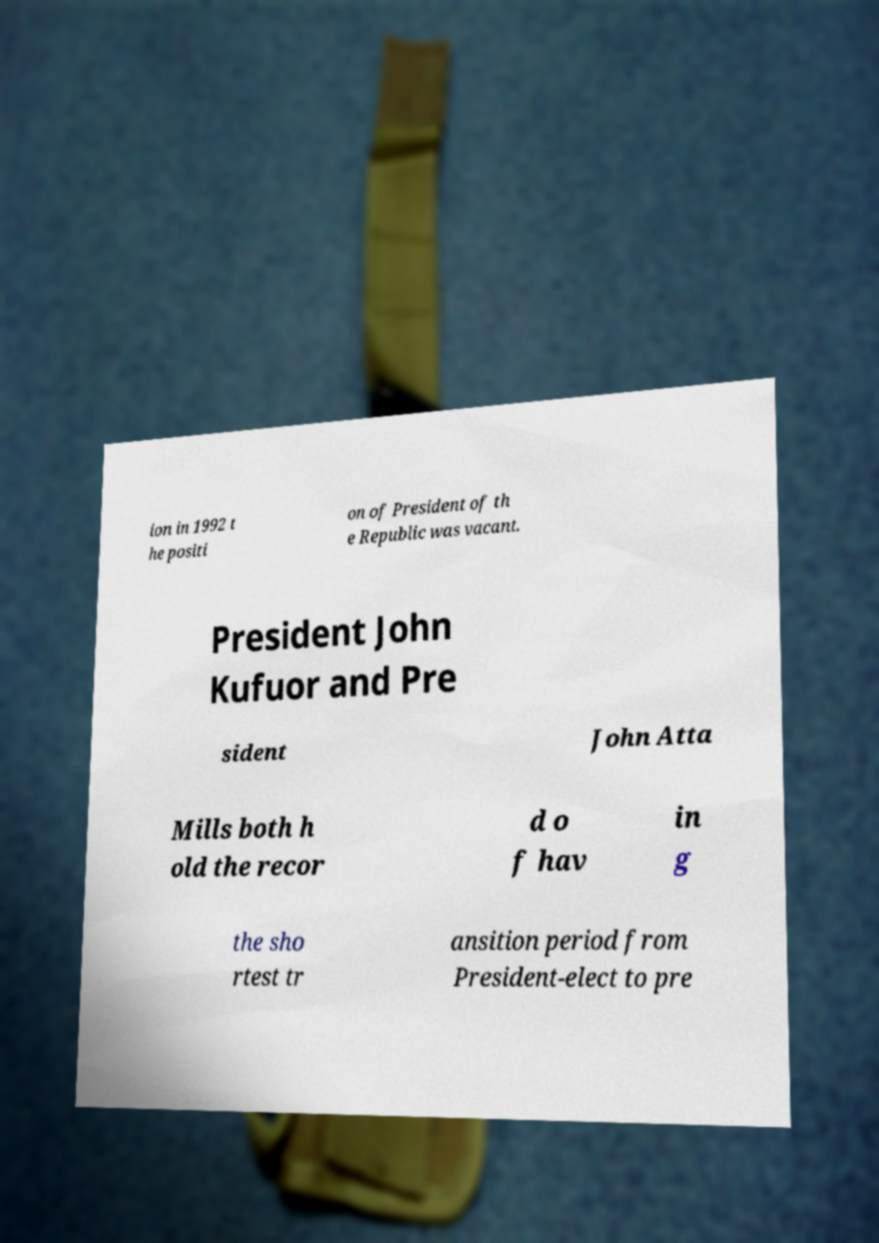Please identify and transcribe the text found in this image. ion in 1992 t he positi on of President of th e Republic was vacant. President John Kufuor and Pre sident John Atta Mills both h old the recor d o f hav in g the sho rtest tr ansition period from President-elect to pre 